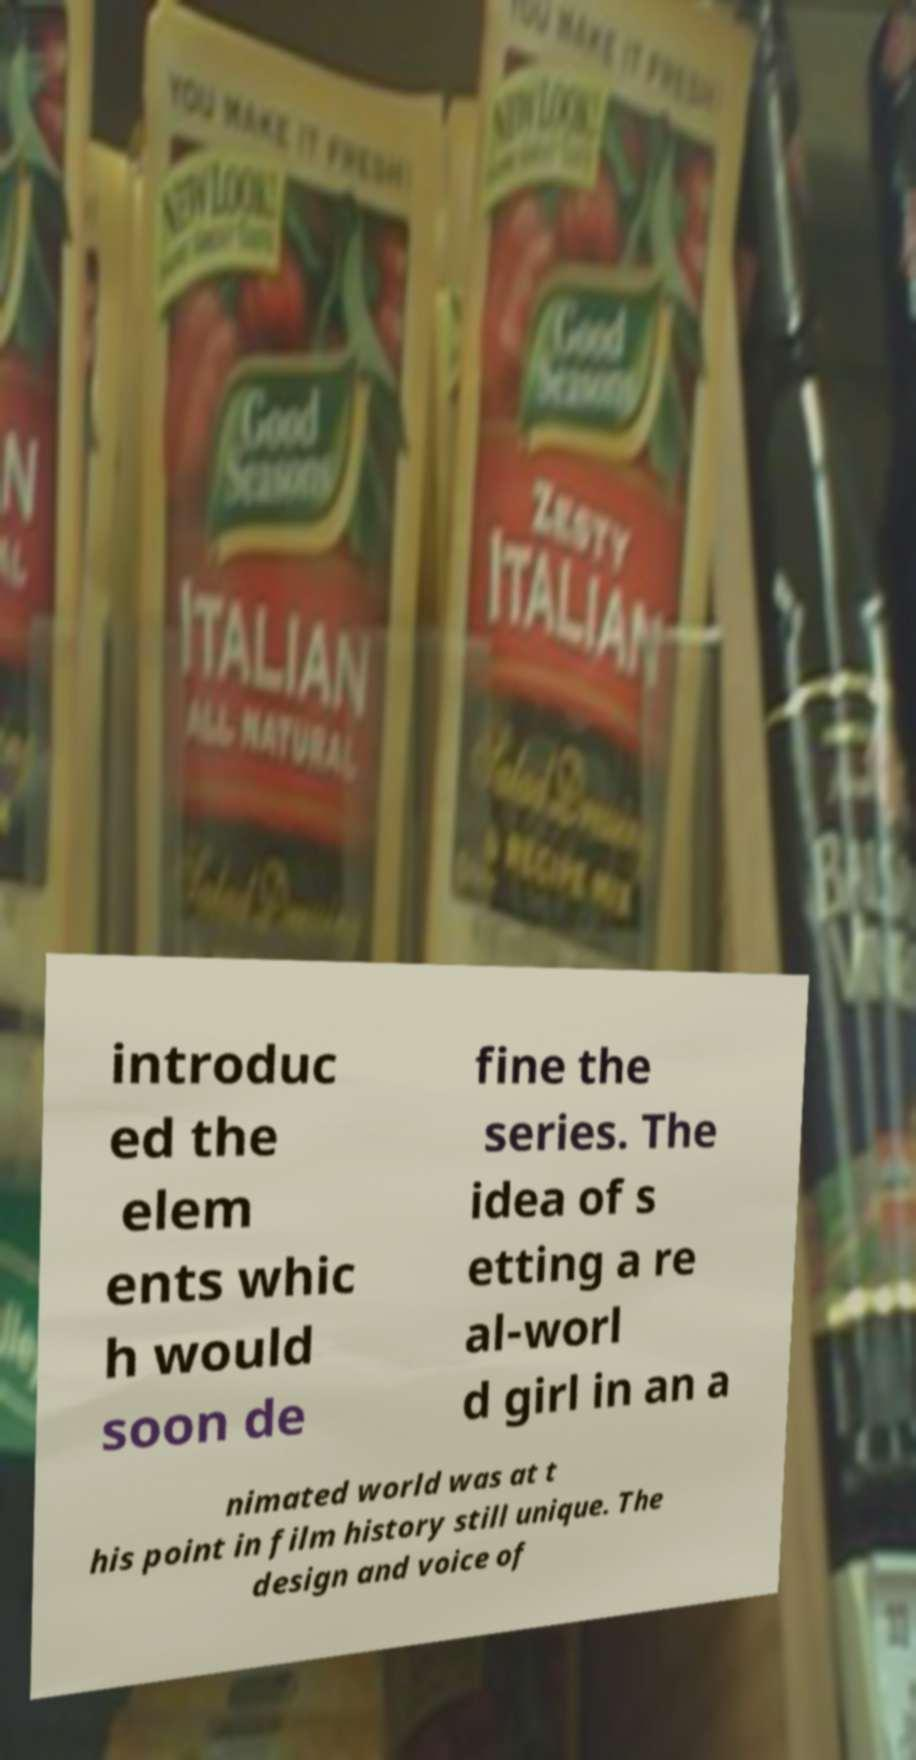I need the written content from this picture converted into text. Can you do that? introduc ed the elem ents whic h would soon de fine the series. The idea of s etting a re al-worl d girl in an a nimated world was at t his point in film history still unique. The design and voice of 